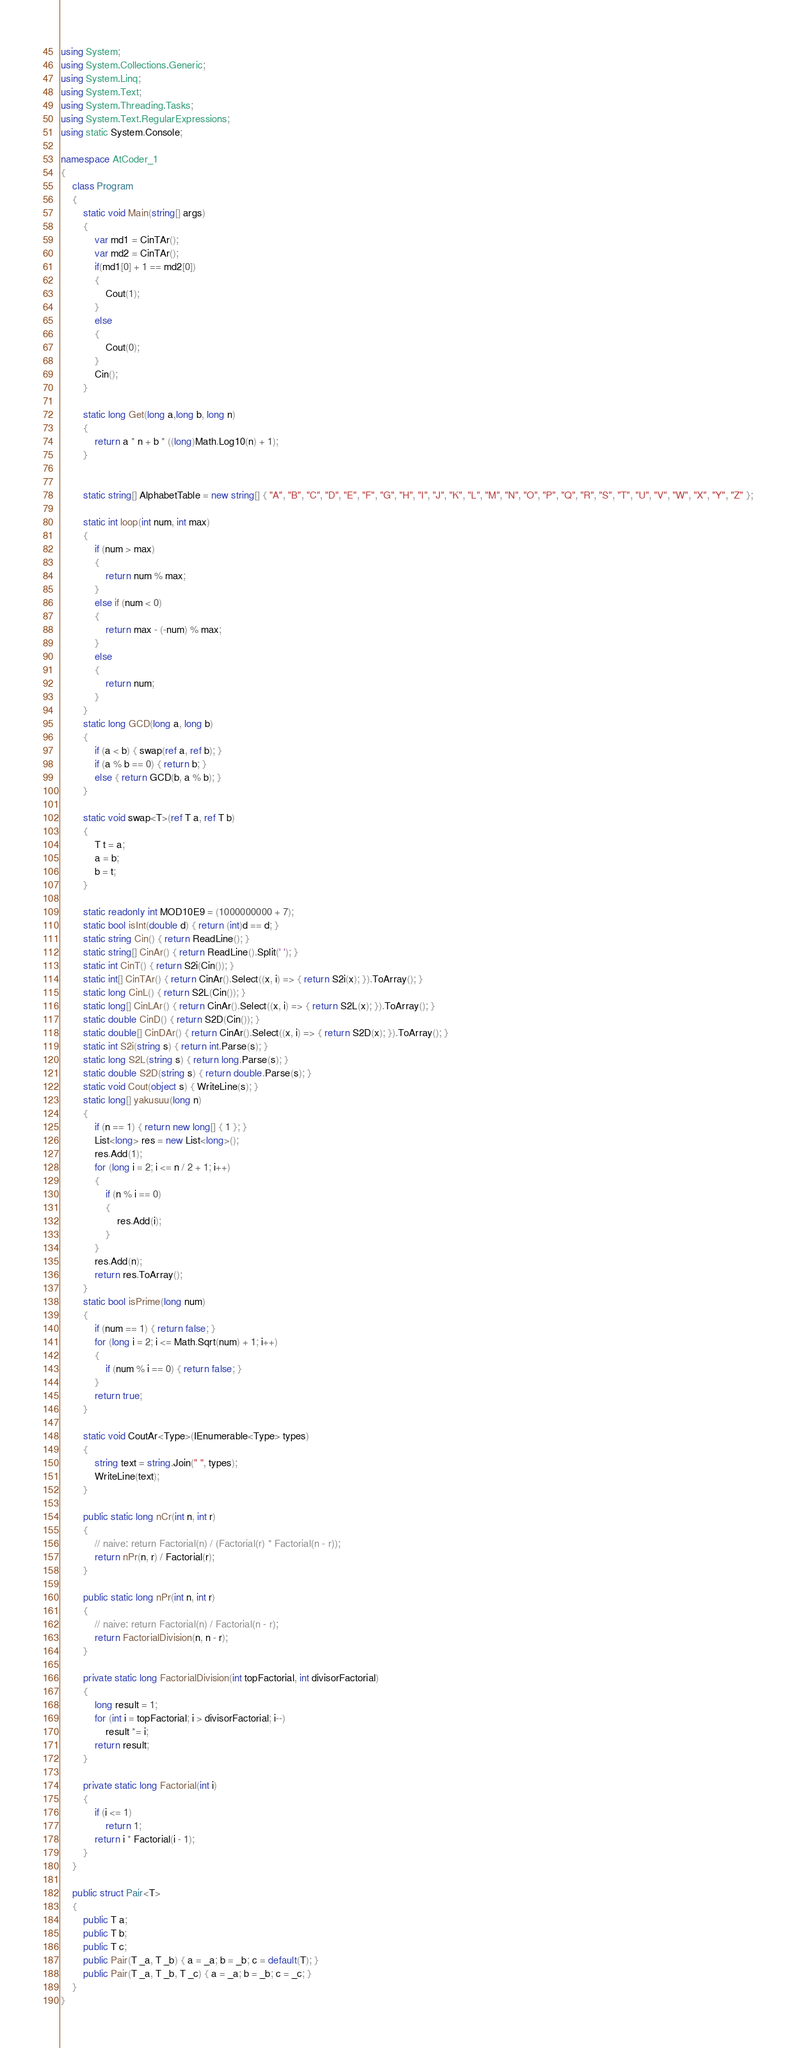Convert code to text. <code><loc_0><loc_0><loc_500><loc_500><_C#_>using System;
using System.Collections.Generic;
using System.Linq;
using System.Text;
using System.Threading.Tasks;
using System.Text.RegularExpressions;
using static System.Console;

namespace AtCoder_1
{
    class Program
    {
        static void Main(string[] args)
        {
            var md1 = CinTAr();
            var md2 = CinTAr();
            if(md1[0] + 1 == md2[0])
            {
                Cout(1);
            }
            else
            {
                Cout(0);
            }
            Cin();
        }

        static long Get(long a,long b, long n)
        {
            return a * n + b * ((long)Math.Log10(n) + 1);
        }


        static string[] AlphabetTable = new string[] { "A", "B", "C", "D", "E", "F", "G", "H", "I", "J", "K", "L", "M", "N", "O", "P", "Q", "R", "S", "T", "U", "V", "W", "X", "Y", "Z" };

        static int loop(int num, int max)
        {
            if (num > max)
            {
                return num % max;
            }
            else if (num < 0)
            {
                return max - (-num) % max;
            }
            else
            {
                return num;
            }
        }
        static long GCD(long a, long b)
        {
            if (a < b) { swap(ref a, ref b); }
            if (a % b == 0) { return b; }
            else { return GCD(b, a % b); }
        }

        static void swap<T>(ref T a, ref T b)
        {
            T t = a;
            a = b;
            b = t;
        }

        static readonly int MOD10E9 = (1000000000 + 7);
        static bool isInt(double d) { return (int)d == d; }
        static string Cin() { return ReadLine(); }
        static string[] CinAr() { return ReadLine().Split(' '); }
        static int CinT() { return S2i(Cin()); }
        static int[] CinTAr() { return CinAr().Select((x, i) => { return S2i(x); }).ToArray(); }
        static long CinL() { return S2L(Cin()); }
        static long[] CinLAr() { return CinAr().Select((x, i) => { return S2L(x); }).ToArray(); }
        static double CinD() { return S2D(Cin()); }
        static double[] CinDAr() { return CinAr().Select((x, i) => { return S2D(x); }).ToArray(); }
        static int S2i(string s) { return int.Parse(s); }
        static long S2L(string s) { return long.Parse(s); }
        static double S2D(string s) { return double.Parse(s); }
        static void Cout(object s) { WriteLine(s); }
        static long[] yakusuu(long n)
        {
            if (n == 1) { return new long[] { 1 }; }
            List<long> res = new List<long>();
            res.Add(1);
            for (long i = 2; i <= n / 2 + 1; i++)
            {
                if (n % i == 0)
                {
                    res.Add(i);
                }
            }
            res.Add(n);
            return res.ToArray();
        }
        static bool isPrime(long num)
        {
            if (num == 1) { return false; }
            for (long i = 2; i <= Math.Sqrt(num) + 1; i++)
            {
                if (num % i == 0) { return false; }
            }
            return true;
        }

        static void CoutAr<Type>(IEnumerable<Type> types)
        {
            string text = string.Join(" ", types);
            WriteLine(text);
        }

        public static long nCr(int n, int r)
        {
            // naive: return Factorial(n) / (Factorial(r) * Factorial(n - r));
            return nPr(n, r) / Factorial(r);
        }

        public static long nPr(int n, int r)
        {
            // naive: return Factorial(n) / Factorial(n - r);
            return FactorialDivision(n, n - r);
        }

        private static long FactorialDivision(int topFactorial, int divisorFactorial)
        {
            long result = 1;
            for (int i = topFactorial; i > divisorFactorial; i--)
                result *= i;
            return result;
        }

        private static long Factorial(int i)
        {
            if (i <= 1)
                return 1;
            return i * Factorial(i - 1);
        }
    }

    public struct Pair<T>
    {
        public T a;
        public T b;
        public T c;
        public Pair(T _a, T _b) { a = _a; b = _b; c = default(T); }
        public Pair(T _a, T _b, T _c) { a = _a; b = _b; c = _c; }
    }
}
</code> 